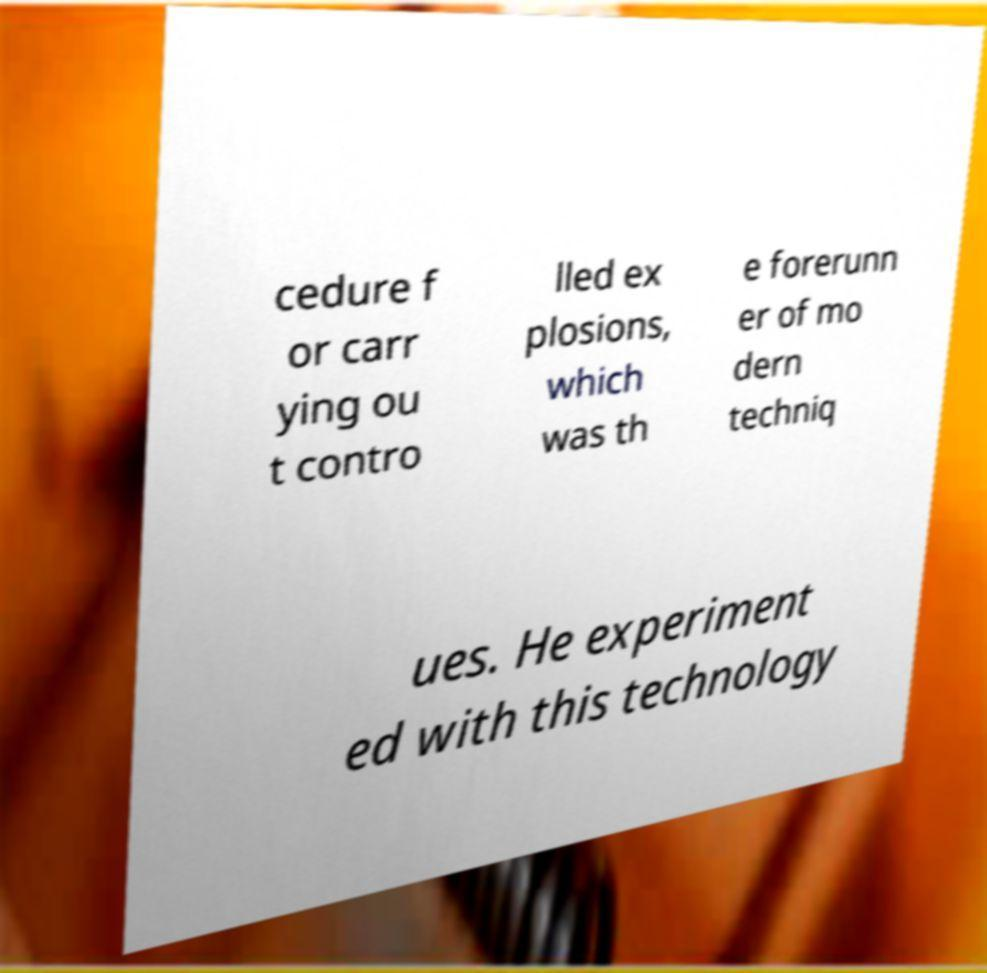What messages or text are displayed in this image? I need them in a readable, typed format. cedure f or carr ying ou t contro lled ex plosions, which was th e forerunn er of mo dern techniq ues. He experiment ed with this technology 